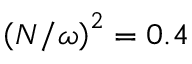<formula> <loc_0><loc_0><loc_500><loc_500>\left ( N / \omega \right ) ^ { 2 } = 0 . 4</formula> 